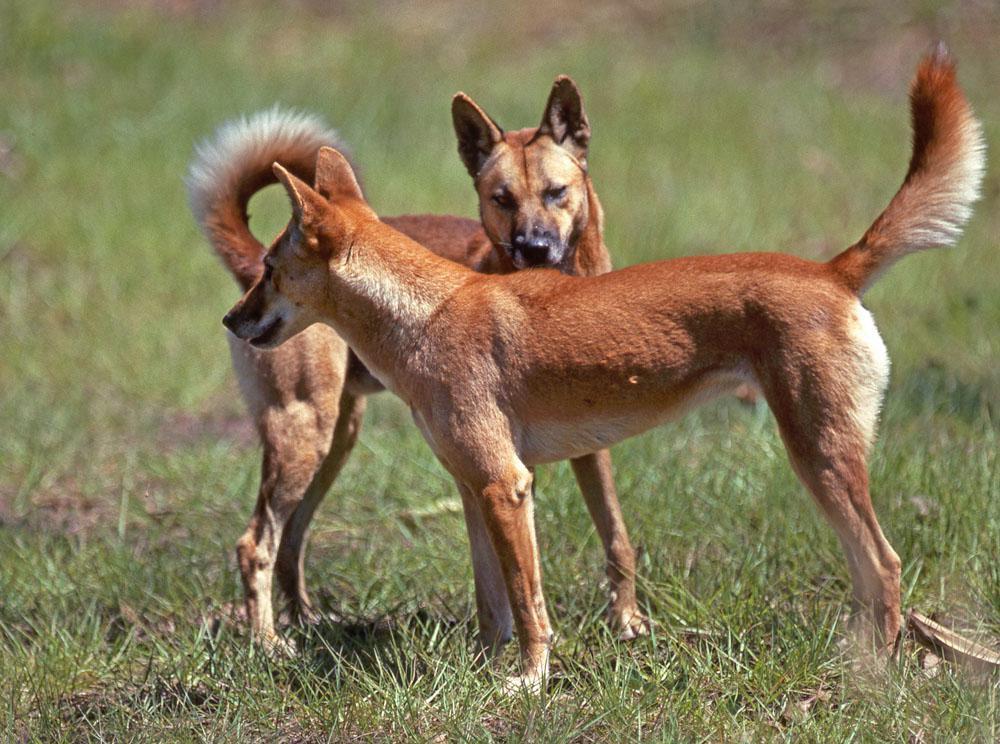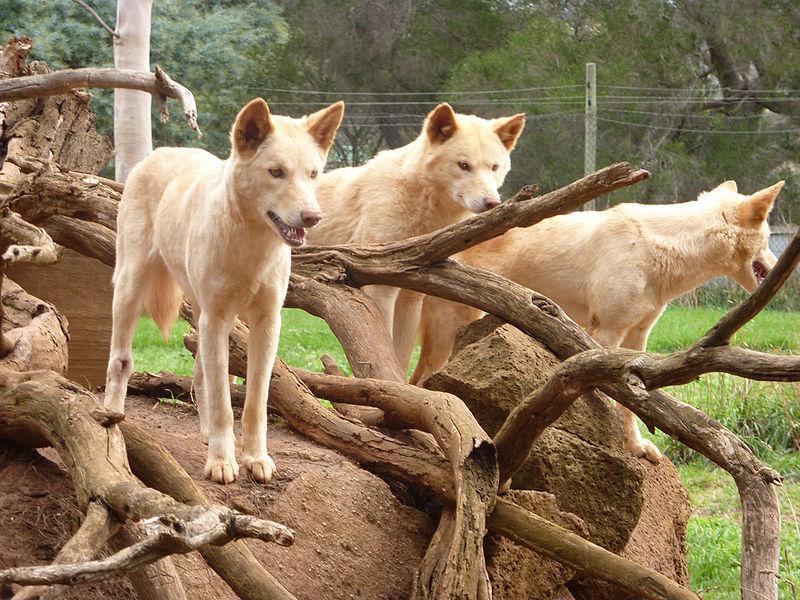The first image is the image on the left, the second image is the image on the right. Analyze the images presented: Is the assertion "There are 3 dogs in one of the images." valid? Answer yes or no. Yes. The first image is the image on the left, the second image is the image on the right. Assess this claim about the two images: "None of the animals are lying down.". Correct or not? Answer yes or no. Yes. 